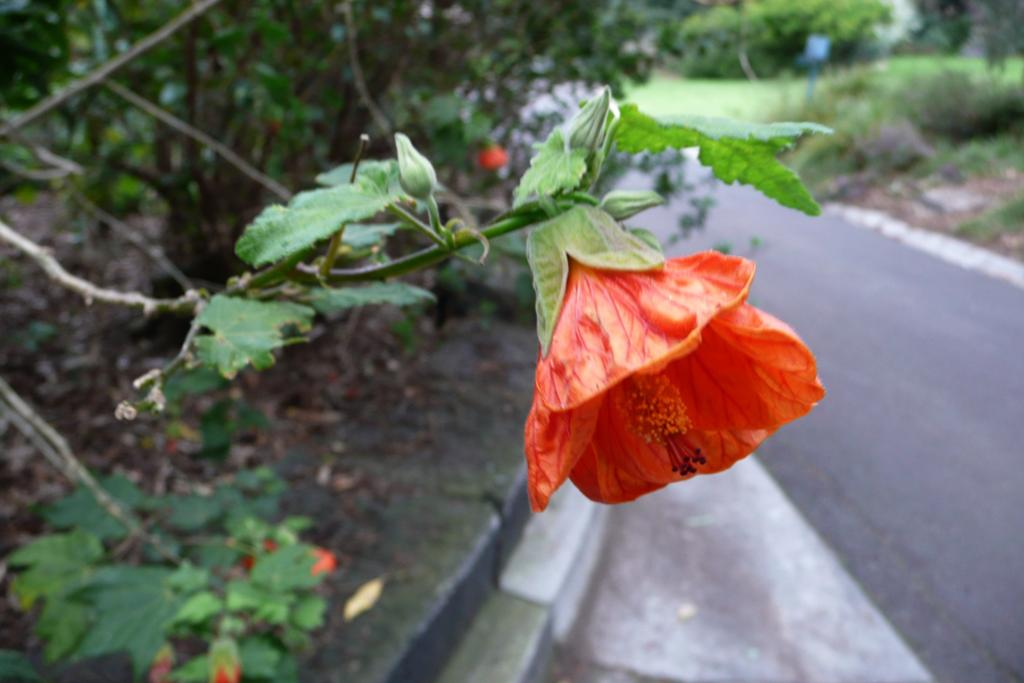What is the main subject of the image? There is a flower in the image. What can be seen in the background of the image? There is a road and trees visible in the background of the image. Are there any other objects present in the background of the image? Yes, there are some unspecified objects in the background of the image. What advice does the flower's daughter give to the manager of the society in the image? There is no mention of a daughter, manager, or society in the image; it only features a flower and the background. 